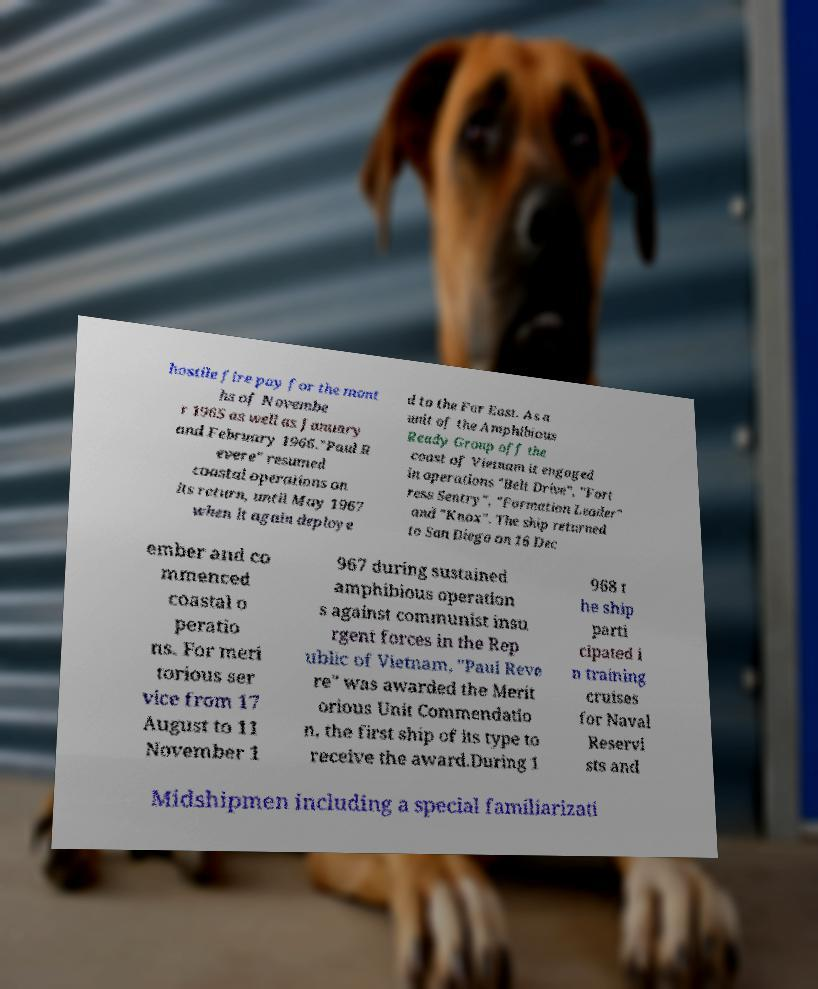Can you read and provide the text displayed in the image?This photo seems to have some interesting text. Can you extract and type it out for me? hostile fire pay for the mont hs of Novembe r 1965 as well as January and February 1966."Paul R evere" resumed coastal operations on its return, until May 1967 when it again deploye d to the Far East. As a unit of the Amphibious Ready Group off the coast of Vietnam it engaged in operations "Belt Drive", "Fort ress Sentry", "Formation Leader" and "Knox". The ship returned to San Diego on 16 Dec ember and co mmenced coastal o peratio ns. For meri torious ser vice from 17 August to 11 November 1 967 during sustained amphibious operation s against communist insu rgent forces in the Rep ublic of Vietnam, "Paul Reve re" was awarded the Merit orious Unit Commendatio n, the first ship of its type to receive the award.During 1 968 t he ship parti cipated i n training cruises for Naval Reservi sts and Midshipmen including a special familiarizati 